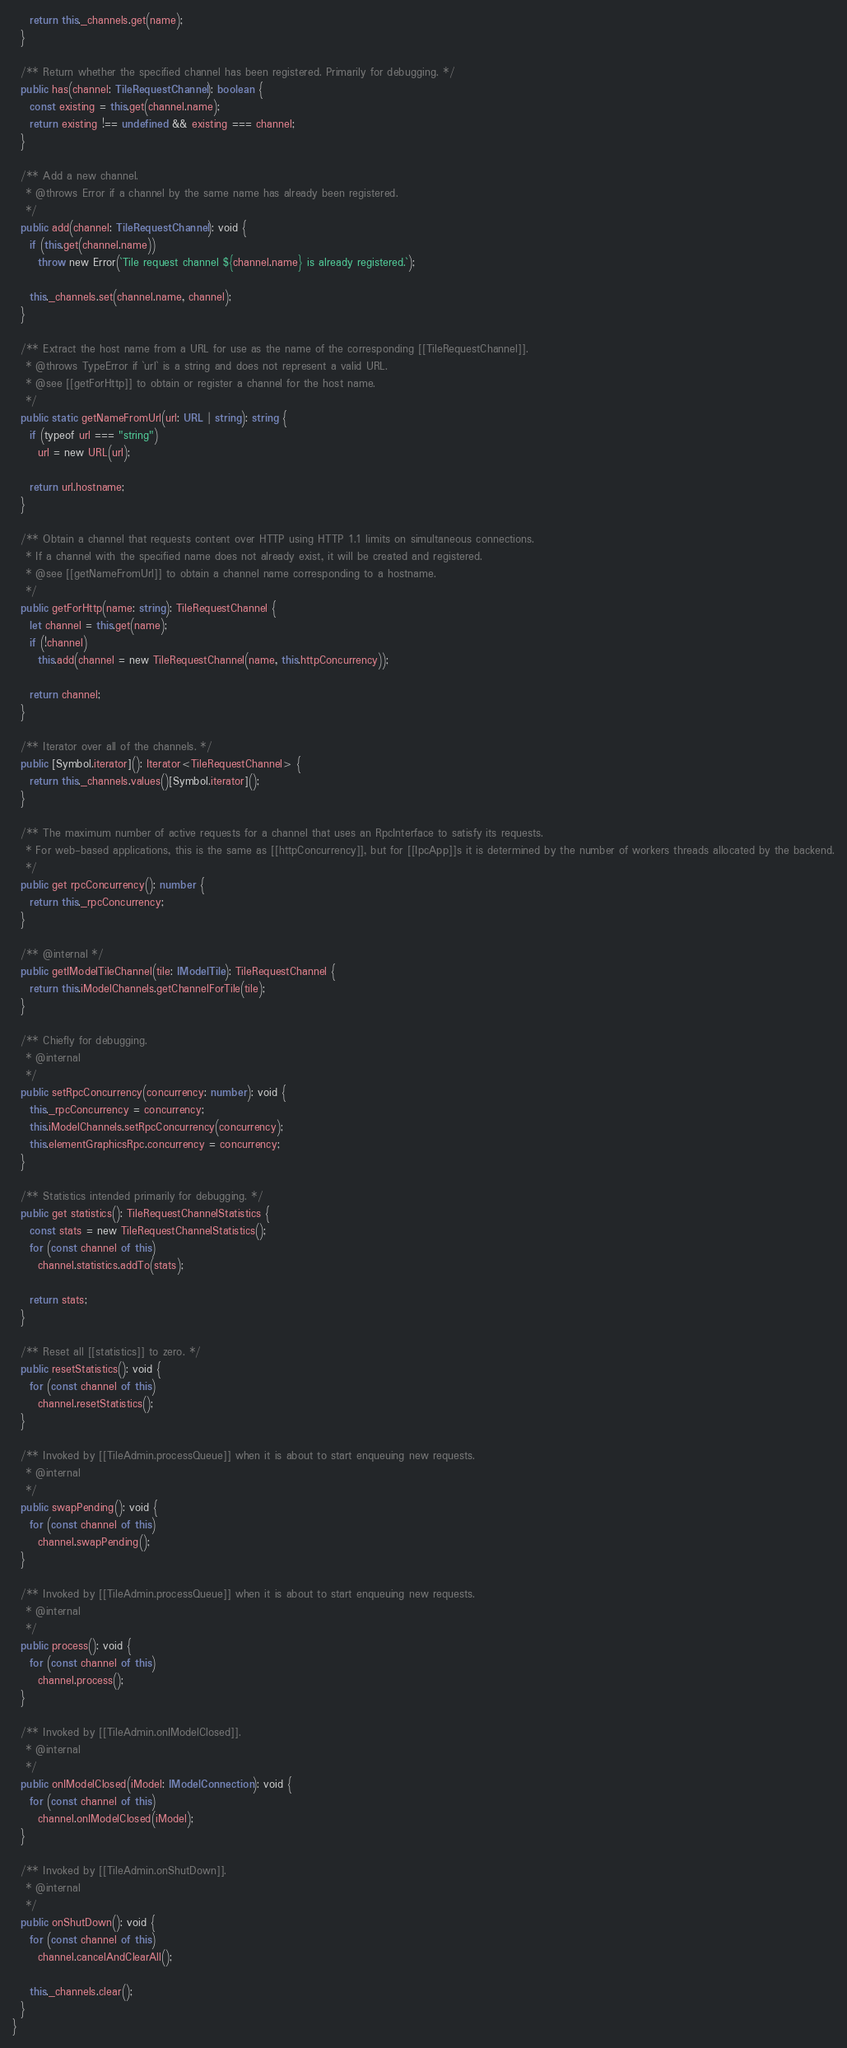Convert code to text. <code><loc_0><loc_0><loc_500><loc_500><_TypeScript_>    return this._channels.get(name);
  }

  /** Return whether the specified channel has been registered. Primarily for debugging. */
  public has(channel: TileRequestChannel): boolean {
    const existing = this.get(channel.name);
    return existing !== undefined && existing === channel;
  }

  /** Add a new channel.
   * @throws Error if a channel by the same name has already been registered.
   */
  public add(channel: TileRequestChannel): void {
    if (this.get(channel.name))
      throw new Error(`Tile request channel ${channel.name} is already registered.`);

    this._channels.set(channel.name, channel);
  }

  /** Extract the host name from a URL for use as the name of the corresponding [[TileRequestChannel]].
   * @throws TypeError if `url` is a string and does not represent a valid URL.
   * @see [[getForHttp]] to obtain or register a channel for the host name.
   */
  public static getNameFromUrl(url: URL | string): string {
    if (typeof url === "string")
      url = new URL(url);

    return url.hostname;
  }

  /** Obtain a channel that requests content over HTTP using HTTP 1.1 limits on simultaneous connections.
   * If a channel with the specified name does not already exist, it will be created and registered.
   * @see [[getNameFromUrl]] to obtain a channel name corresponding to a hostname.
   */
  public getForHttp(name: string): TileRequestChannel {
    let channel = this.get(name);
    if (!channel)
      this.add(channel = new TileRequestChannel(name, this.httpConcurrency));

    return channel;
  }

  /** Iterator over all of the channels. */
  public [Symbol.iterator](): Iterator<TileRequestChannel> {
    return this._channels.values()[Symbol.iterator]();
  }

  /** The maximum number of active requests for a channel that uses an RpcInterface to satisfy its requests.
   * For web-based applications, this is the same as [[httpConcurrency]], but for [[IpcApp]]s it is determined by the number of workers threads allocated by the backend.
   */
  public get rpcConcurrency(): number {
    return this._rpcConcurrency;
  }

  /** @internal */
  public getIModelTileChannel(tile: IModelTile): TileRequestChannel {
    return this.iModelChannels.getChannelForTile(tile);
  }

  /** Chiefly for debugging.
   * @internal
   */
  public setRpcConcurrency(concurrency: number): void {
    this._rpcConcurrency = concurrency;
    this.iModelChannels.setRpcConcurrency(concurrency);
    this.elementGraphicsRpc.concurrency = concurrency;
  }

  /** Statistics intended primarily for debugging. */
  public get statistics(): TileRequestChannelStatistics {
    const stats = new TileRequestChannelStatistics();
    for (const channel of this)
      channel.statistics.addTo(stats);

    return stats;
  }

  /** Reset all [[statistics]] to zero. */
  public resetStatistics(): void {
    for (const channel of this)
      channel.resetStatistics();
  }

  /** Invoked by [[TileAdmin.processQueue]] when it is about to start enqueuing new requests.
   * @internal
   */
  public swapPending(): void {
    for (const channel of this)
      channel.swapPending();
  }

  /** Invoked by [[TileAdmin.processQueue]] when it is about to start enqueuing new requests.
   * @internal
   */
  public process(): void {
    for (const channel of this)
      channel.process();
  }

  /** Invoked by [[TileAdmin.onIModelClosed]].
   * @internal
   */
  public onIModelClosed(iModel: IModelConnection): void {
    for (const channel of this)
      channel.onIModelClosed(iModel);
  }

  /** Invoked by [[TileAdmin.onShutDown]].
   * @internal
   */
  public onShutDown(): void {
    for (const channel of this)
      channel.cancelAndClearAll();

    this._channels.clear();
  }
}
</code> 